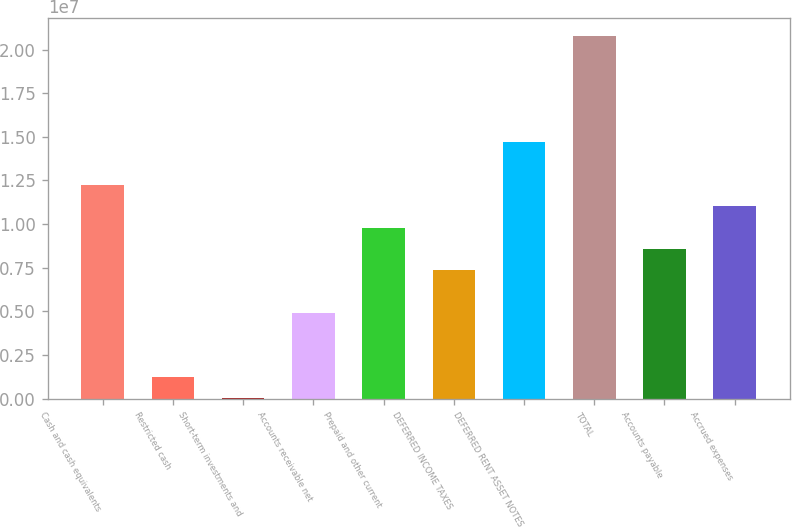Convert chart. <chart><loc_0><loc_0><loc_500><loc_500><bar_chart><fcel>Cash and cash equivalents<fcel>Restricted cash<fcel>Short-term investments and<fcel>Accounts receivable net<fcel>Prepaid and other current<fcel>DEFERRED INCOME TAXES<fcel>DEFERRED RENT ASSET NOTES<fcel>TOTAL<fcel>Accounts payable<fcel>Accrued expenses<nl><fcel>1.22424e+07<fcel>1.24428e+06<fcel>22270<fcel>4.91032e+06<fcel>9.79837e+06<fcel>7.35434e+06<fcel>1.46864e+07<fcel>2.07965e+07<fcel>8.57636e+06<fcel>1.10204e+07<nl></chart> 